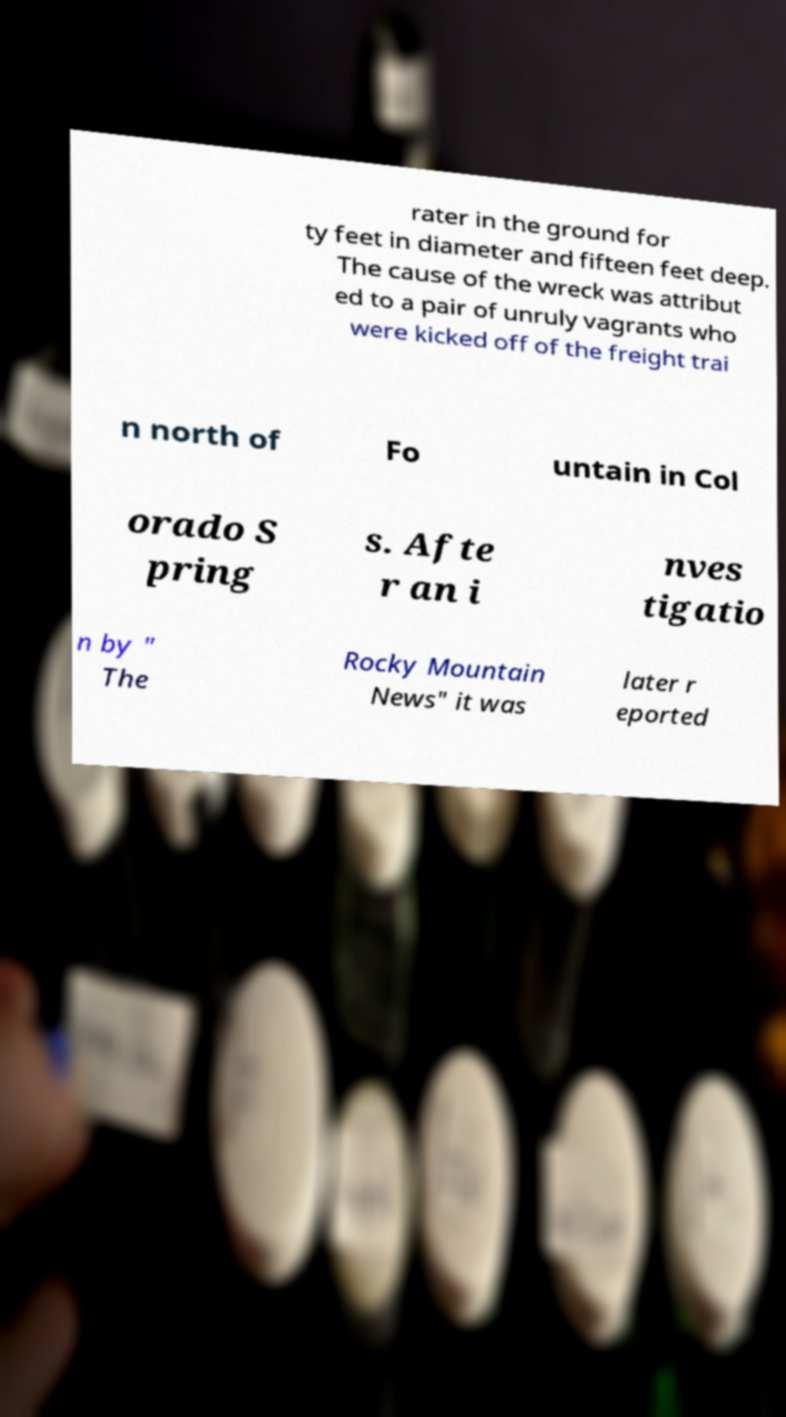Please read and relay the text visible in this image. What does it say? rater in the ground for ty feet in diameter and fifteen feet deep. The cause of the wreck was attribut ed to a pair of unruly vagrants who were kicked off of the freight trai n north of Fo untain in Col orado S pring s. Afte r an i nves tigatio n by " The Rocky Mountain News" it was later r eported 